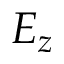<formula> <loc_0><loc_0><loc_500><loc_500>E _ { z }</formula> 